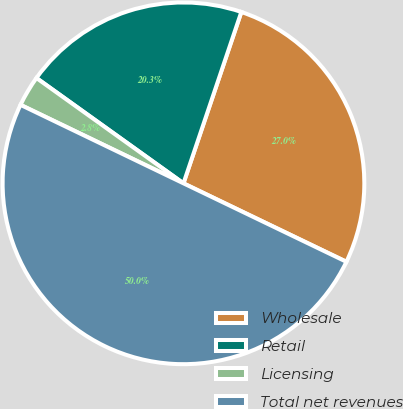<chart> <loc_0><loc_0><loc_500><loc_500><pie_chart><fcel>Wholesale<fcel>Retail<fcel>Licensing<fcel>Total net revenues<nl><fcel>26.96%<fcel>20.29%<fcel>2.75%<fcel>50.0%<nl></chart> 